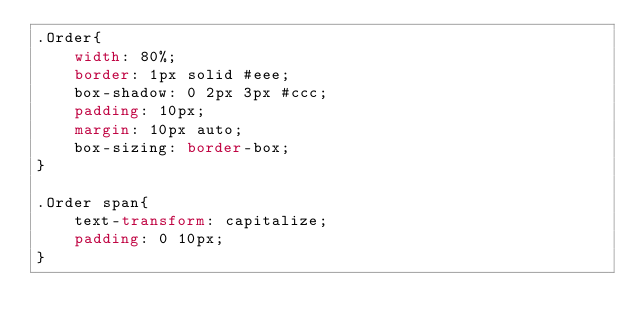Convert code to text. <code><loc_0><loc_0><loc_500><loc_500><_CSS_>.Order{
    width: 80%;
    border: 1px solid #eee;
    box-shadow: 0 2px 3px #ccc;
    padding: 10px;
    margin: 10px auto;
    box-sizing: border-box;
}

.Order span{
    text-transform: capitalize;
    padding: 0 10px;
}</code> 